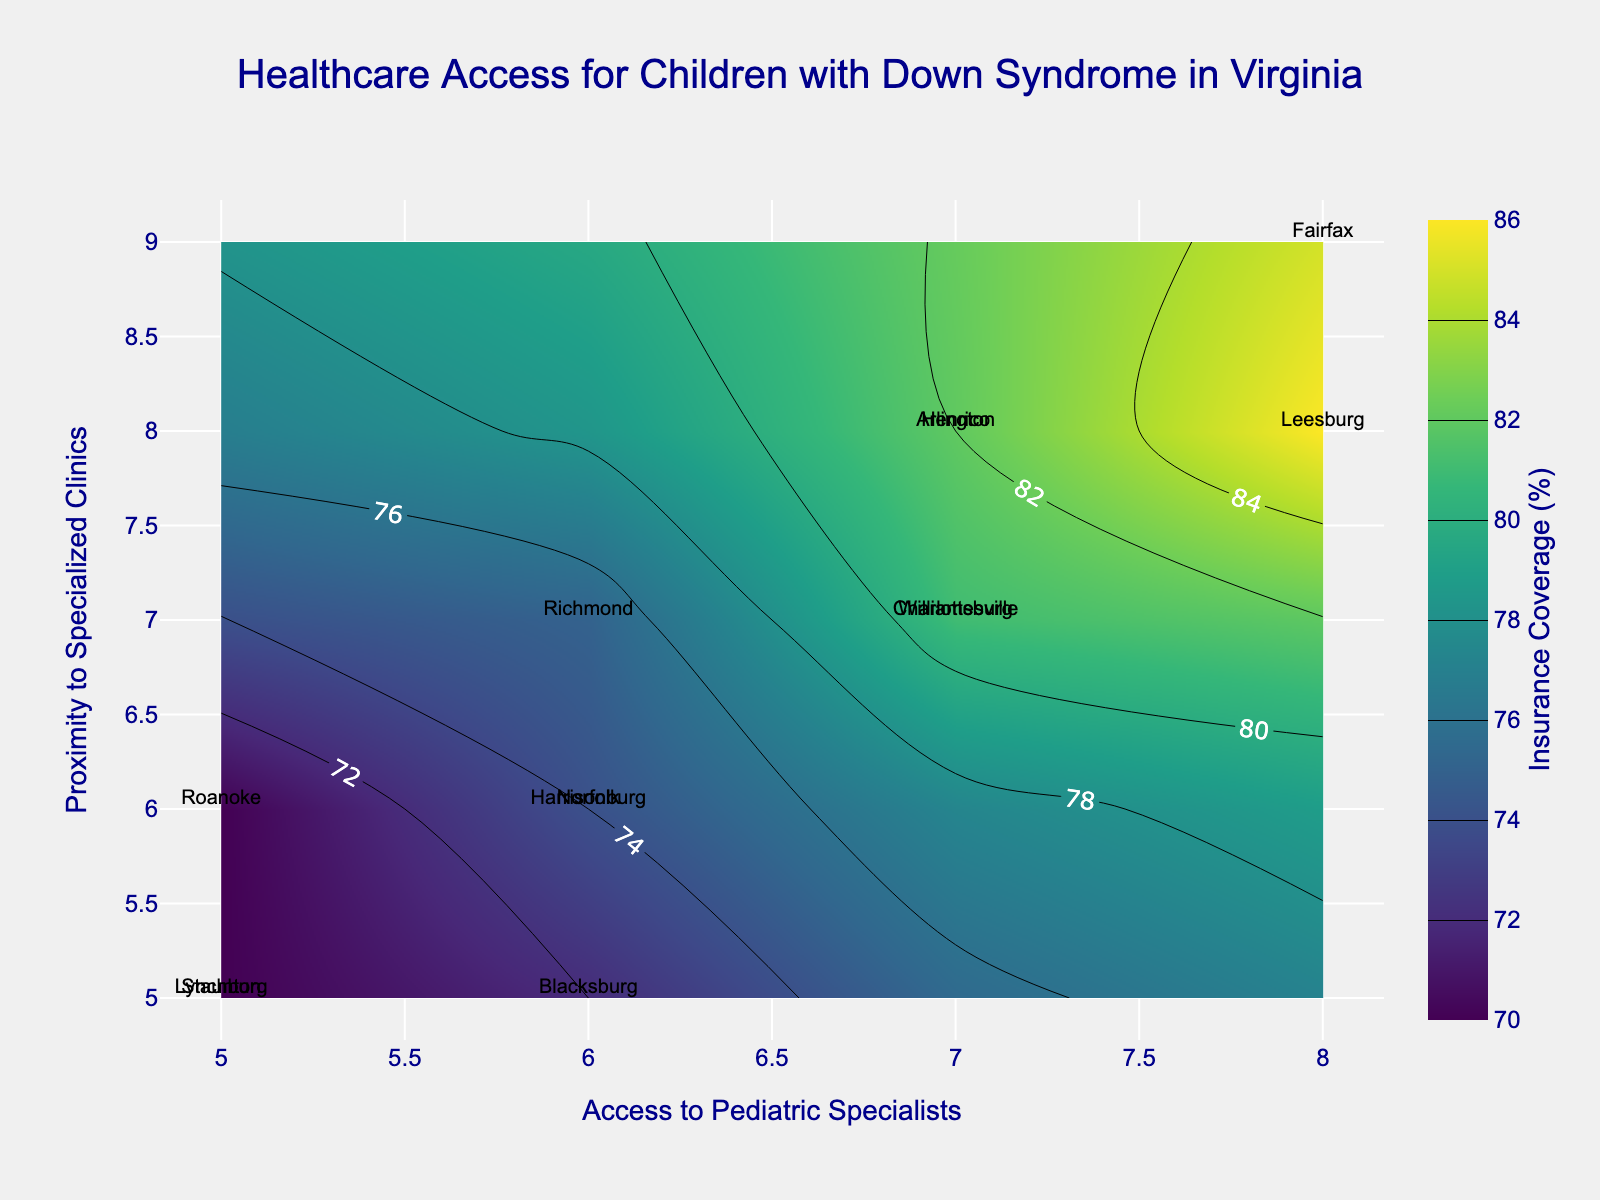what is the title of the figure? The title of the figure is typically found at the top center of the plot layout. In this case, the title is "Healthcare Access for Children with Down Syndrome in Virginia" as seen from the visual information available.
Answer: Healthcare Access for Children with Down Syndrome in Virginia how many counties are labeled on the plot? The number of labeled counties can be determined by counting the unique labels for each data point on the plot. The labels in the figure point out each county from the provided data. A quick count shows there are labels for Fairfax, Henrico, Richmond, Roanoke, Arlington, Norfolk, Charlottesville, Lynchburg, Blacksburg, Harrisonburg, Staunton, Williamsburg, and Leesburg, totaling 13 counties.
Answer: 13 which county has the highest insurance coverage? The highest insurance coverage is indicated by the contour's peak areas and the corresponding labels. By examining the highest value for Insurance_Coverage on the contour plot, the county with an insurance coverage of 86% which is the peak in the dataset, is Leesburg.
Answer: Leesburg what range of values is displayed on the color bar for insurance coverage? The color bar on the right side of the plot provides a scale indicating the range of values for Insurance Coverage. Reading off this bar, we can see the minimum value starts around 68% and the maximum value approaches 86%.
Answer: 68% to 86% which county is represented by the data point located at (8, 9) on the axes? Referencing the plot's axes for 'Access to Pediatric Specialists' and 'Proximity to Specialized Clinics', we locate the data point where x=8 and y=9. The corresponding label at this coordinate is Fairfax.
Answer: Fairfax which counties have equal access to pediatric specialists and how do their proximities to specialized clinics compare? Counties with equal 'Access to Pediatric Specialists' can be identified by matching x-values. Here, both Fairfax and Leesburg have an access value of 8. Comparing proximities, Fairfax has a 'Proximity to Specialized Clinics' value of 9, whereas Leesburg has a value of 8.
Answer: Fairfax and Leesburg; 9 and 8 what is the average insurance coverage for counties with 5 access to pediatric specialists? Identifying the counties with an x-value of 5, we have Roanoke, Lynchburg, and Staunton. Their respective 'Insurance Coverage' values are 70, 68, and 70. Calculating the average: (70 + 68 + 70) / 3 = 69.33%
Answer: 69.33% among charlottesville, virginia, and williamsburg, which county has better proximity to specialized clinics? By locating the labels for Charlottesville and Williamsburg on the plot and checking their y-values on the 'Proximity to Specialized Clinics' axis, we see that Charlottesville has a value of 7 and Williamsburg also has a value of 7. Therefore, both have the same proximity to specialized clinics.
Answer: Same (7) which county has the lowest access to pediatric specialists and what is the insurance coverage for that county? By identifying the lowest x-value on the 'Access to Pediatric Specialists' axis, Lynchburg and Staunton both have the lowest access value of 5. Checking their corresponding 'Insurance Coverage', Lynchburg has 68% and Staunton has 70%. The question asks for which county specifically for one, choosing the lowest coverage is Lynchburg.
Answer: Lynchburg; 68% are there any counties with equal values for both access to pediatric specialists and proximity to specialized clinics? By examining where x and y values are equal, we can use the data points on the plot. Locations where this occurs include Lynchburg and Staunton with both having equal values of 5 for both metrics.
Answer: Lynchburg, Staunton 